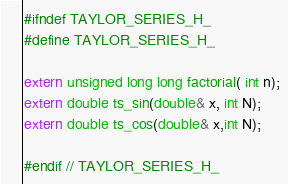<code> <loc_0><loc_0><loc_500><loc_500><_C_>#ifndef TAYLOR_SERIES_H_
#define TAYLOR_SERIES_H_

extern unsigned long long factorial( int n);
extern double ts_sin(double& x, int N);
extern double ts_cos(double& x,int N);

#endif // TAYLOR_SERIES_H_


</code> 